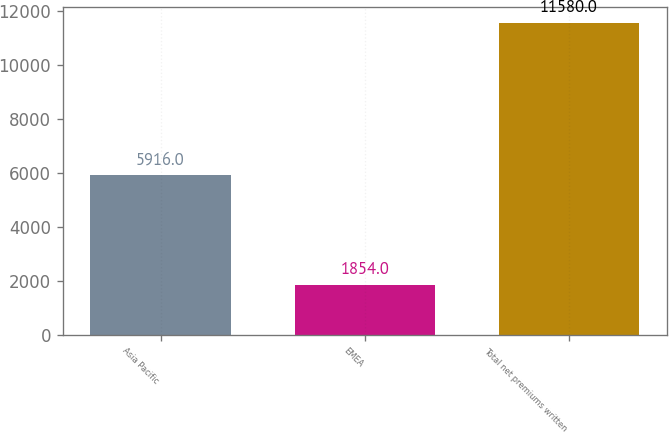Convert chart. <chart><loc_0><loc_0><loc_500><loc_500><bar_chart><fcel>Asia Pacific<fcel>EMEA<fcel>Total net premiums written<nl><fcel>5916<fcel>1854<fcel>11580<nl></chart> 